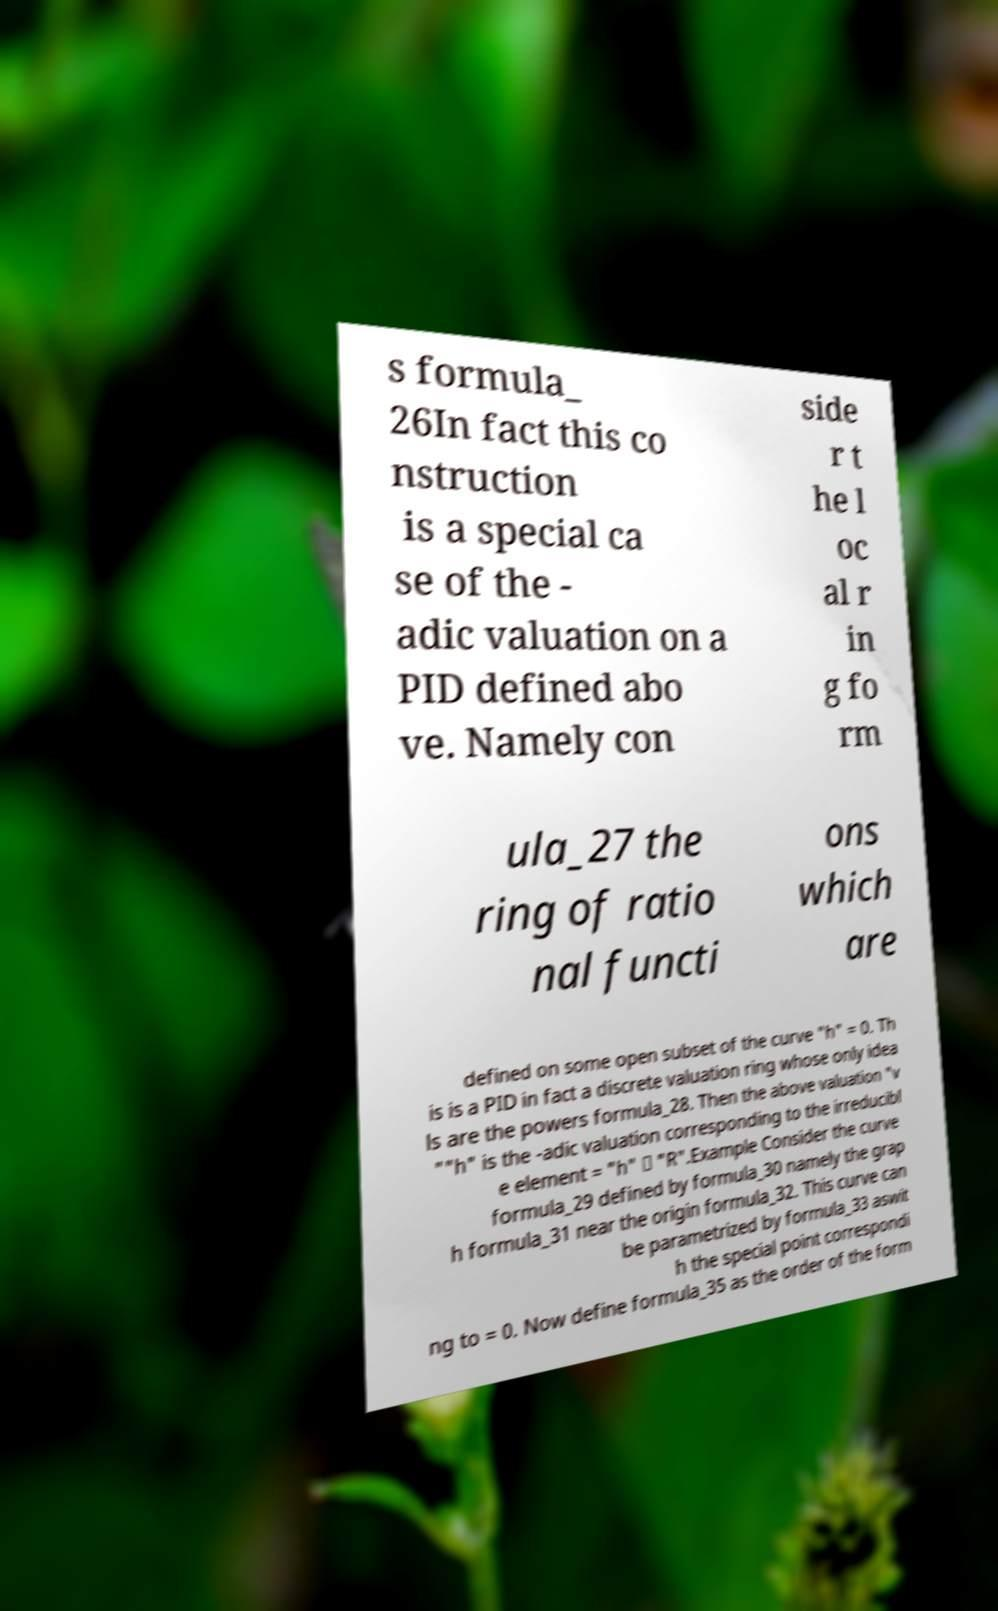I need the written content from this picture converted into text. Can you do that? s formula_ 26In fact this co nstruction is a special ca se of the - adic valuation on a PID defined abo ve. Namely con side r t he l oc al r in g fo rm ula_27 the ring of ratio nal functi ons which are defined on some open subset of the curve "h" = 0. Th is is a PID in fact a discrete valuation ring whose only idea ls are the powers formula_28. Then the above valuation "v ""h" is the -adic valuation corresponding to the irreducibl e element = "h" ∈ "R".Example Consider the curve formula_29 defined by formula_30 namely the grap h formula_31 near the origin formula_32. This curve can be parametrized by formula_33 aswit h the special point correspondi ng to = 0. Now define formula_35 as the order of the form 